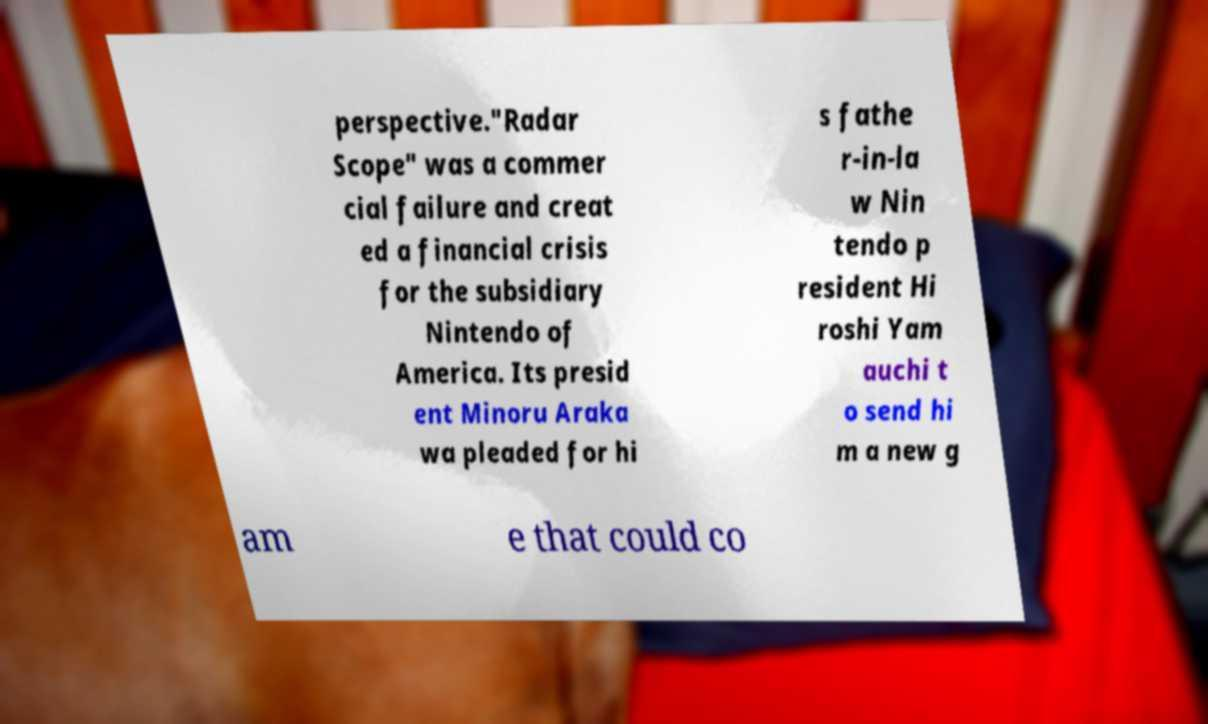Could you assist in decoding the text presented in this image and type it out clearly? perspective."Radar Scope" was a commer cial failure and creat ed a financial crisis for the subsidiary Nintendo of America. Its presid ent Minoru Araka wa pleaded for hi s fathe r-in-la w Nin tendo p resident Hi roshi Yam auchi t o send hi m a new g am e that could co 